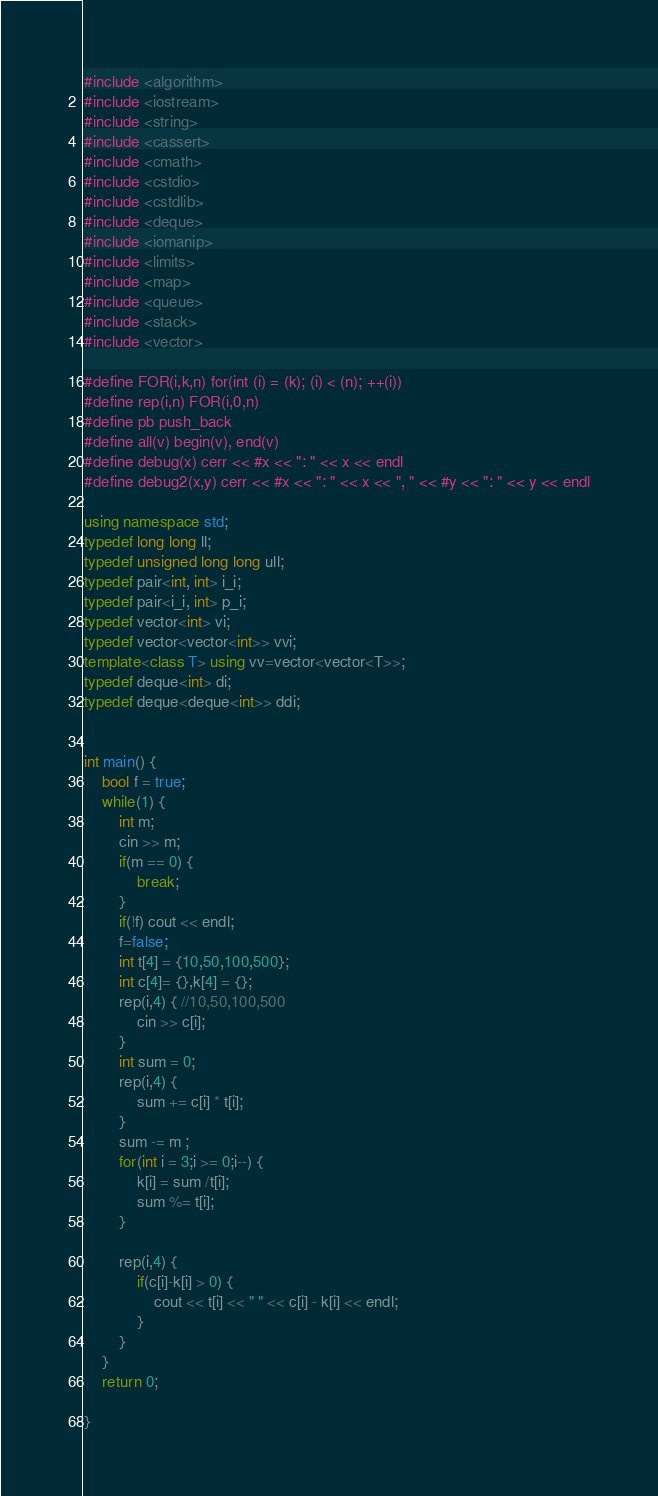<code> <loc_0><loc_0><loc_500><loc_500><_C++_>#include <algorithm>
#include <iostream>
#include <string>
#include <cassert>
#include <cmath>
#include <cstdio>
#include <cstdlib>
#include <deque>
#include <iomanip>
#include <limits>
#include <map>
#include <queue>
#include <stack>
#include <vector>

#define FOR(i,k,n) for(int (i) = (k); (i) < (n); ++(i))
#define rep(i,n) FOR(i,0,n)
#define pb push_back
#define all(v) begin(v), end(v)
#define debug(x) cerr << #x << ": " << x << endl
#define debug2(x,y) cerr << #x << ": " << x << ", " << #y << ": " << y << endl

using namespace std;
typedef long long ll;
typedef unsigned long long ull;
typedef pair<int, int> i_i;
typedef pair<i_i, int> p_i;
typedef vector<int> vi;
typedef vector<vector<int>> vvi;
template<class T> using vv=vector<vector<T>>;
typedef deque<int> di;
typedef deque<deque<int>> ddi;


int main() {
    bool f = true;
    while(1) {
        int m;
        cin >> m;
        if(m == 0) {
            break;
        }
        if(!f) cout << endl;
        f=false;
        int t[4] = {10,50,100,500};
        int c[4]= {},k[4] = {}; 
        rep(i,4) { //10,50,100,500
            cin >> c[i];
        }
        int sum = 0; 
        rep(i,4) {
            sum += c[i] * t[i];
        }
        sum -= m ;
        for(int i = 3;i >= 0;i--) {
            k[i] = sum /t[i];
            sum %= t[i];
        }
        
        rep(i,4) {
            if(c[i]-k[i] > 0) {
                cout << t[i] << " " << c[i] - k[i] << endl;
            }
        }
    }
    return 0;

}</code> 